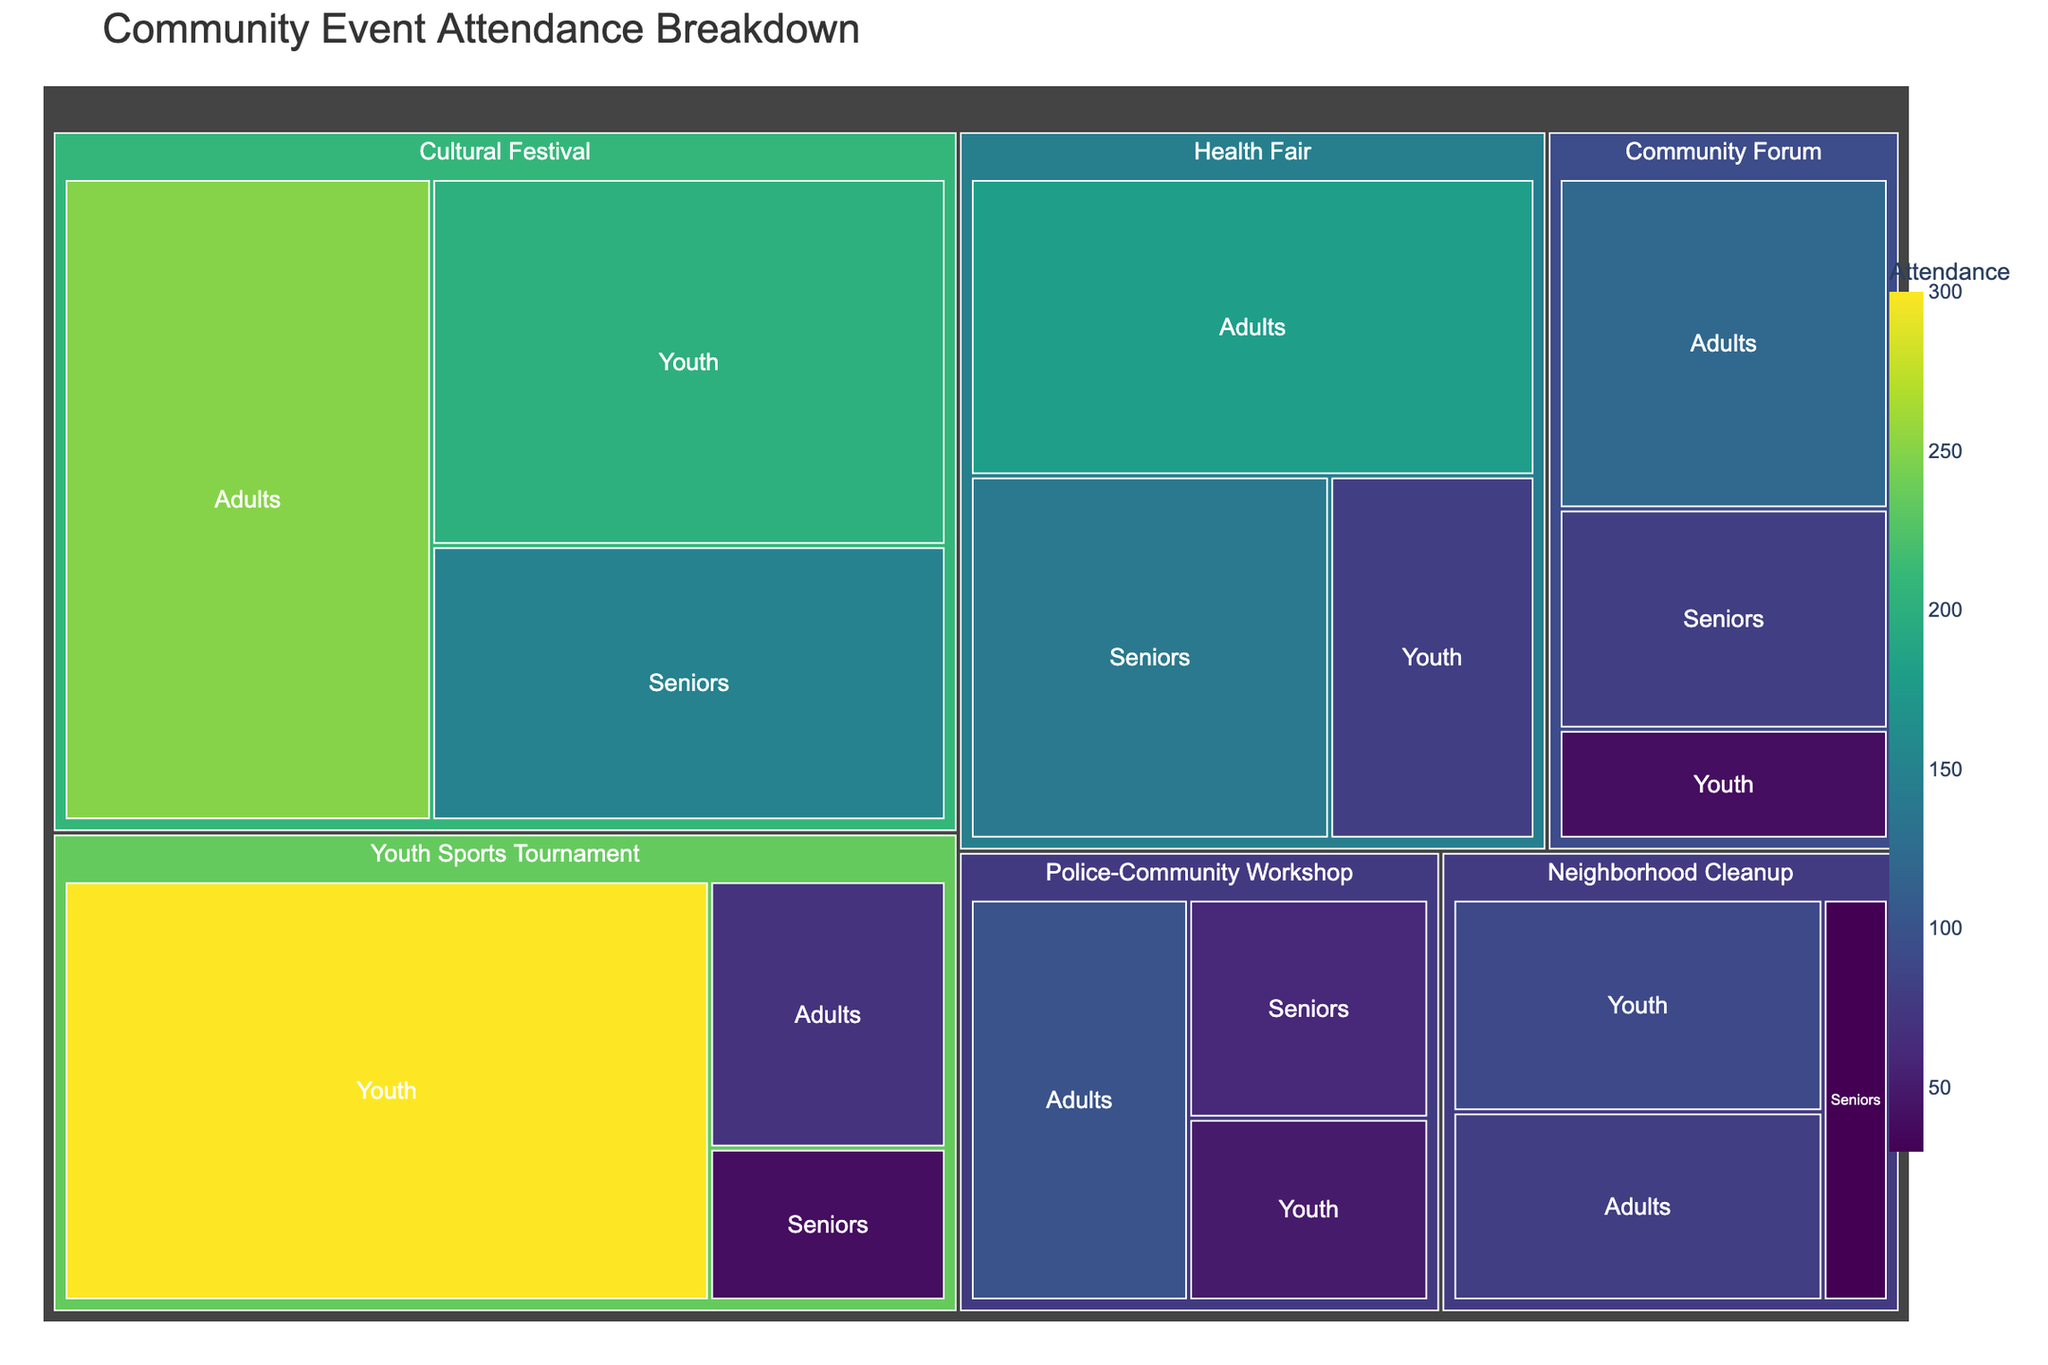What is the total attendance for the "Youth Sports Tournament"? The "Youth Sports Tournament" attendance includes Adults, Seniors, and Youth. Add these attendance numbers: 70 (Adults) + 40 (Seniors) + 300 (Youth) = 410
Answer: 410 Which event type had the highest attendance from Adults? Check the attendance numbers for Adults in each event type. The highest number for Adults is in the "Cultural Festival" with 250 attendees.
Answer: Cultural Festival How much more attendance did "Cultural Festival" receive from Youth compared to "Community Forum"? The attendance from Youth for "Cultural Festival" is 200 and for "Community Forum" it is 40. The difference is 200 - 40 = 160
Answer: 160 Which age group contributed the least to "Health Fair" attendance? Compare the attendance numbers for each age group in the "Health Fair": Adults (180), Seniors (140), and Youth (80). The lowest is Youth.
Answer: Youth What is the total attendance for all event types combined? To find the total, sum up all the attendance numbers across all event types and age groups: 120 + 80 + 40 + 250 + 150 + 200 + 80 + 30 + 90 + 100 + 60 + 50 + 180 + 140 + 80 + 70 + 40 + 300 = 1960
Answer: 1960 Which event type had the most balanced attendance among different age groups? Compare the attendance numbers within each event type to see which one has the closest values across Adults, Seniors, and Youth. "Police-Community Workshop" has 100 (Adults), 60 (Seniors), and 50 (Youth), which are relatively balanced.
Answer: Police-Community Workshop What is the percentage of Seniors' attendance in the "Neighborhood Cleanup" relative to its total attendance? The total attendance for "Neighborhood Cleanup" is 200 (80 Adults + 30 Seniors + 90 Youth). The percentage for Seniors is (30/200) * 100 = 15%
Answer: 15% Which age group had the highest total attendance across all event types? Sum up the attendance for each age group across all events. Adults: 120 + 250 + 80 + 100 + 180 + 70 = 800, Seniors: 80 + 150 + 30 + 60 + 140 + 40 = 500, Youth: 40 + 200 + 90 + 50 + 80 + 300 = 760; Adults have the highest combined total.
Answer: Adults How does the attendance of "Community Forum" compare to "Health Fair" for Youth? The attendance of Youth at "Community Forum" is 40 and at "Health Fair" is 80. "Health Fair" has double the attendance of Youth compared to "Community Forum".
Answer: Health Fair What is the average attendance of Youth across all event types? Sum the Youth attendance across all events: 40 + 200 + 90 + 50 + 80 + 300 = 760, then divide by the number of events (6): 760 / 6 ≈ 127
Answer: 127 